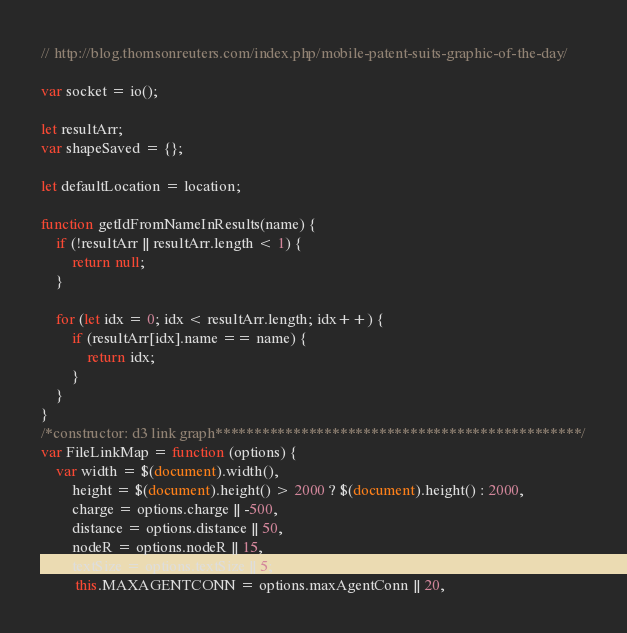<code> <loc_0><loc_0><loc_500><loc_500><_JavaScript_>// http://blog.thomsonreuters.com/index.php/mobile-patent-suits-graphic-of-the-day/

var socket = io();

let resultArr;
var shapeSaved = {};

let defaultLocation = location;

function getIdFromNameInResults(name) {
    if (!resultArr || resultArr.length < 1) {
        return null;
    }
    
    for (let idx = 0; idx < resultArr.length; idx++) {
        if (resultArr[idx].name == name) {
            return idx;
        }
    }
}
/*constructor: d3 link graph***********************************************/
var FileLinkMap = function (options) {
    var width = $(document).width(),
        height = $(document).height() > 2000 ? $(document).height() : 2000,
        charge = options.charge || -500,
        distance = options.distance || 50,
        nodeR = options.nodeR || 15,
        textSize = options.textSize || 5;
         this.MAXAGENTCONN = options.maxAgentConn || 20,</code> 